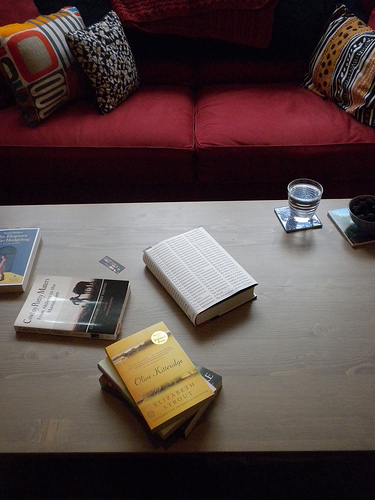<image>
Is there a glass to the left of the book? No. The glass is not to the left of the book. From this viewpoint, they have a different horizontal relationship. Is the water in the coffee? No. The water is not contained within the coffee. These objects have a different spatial relationship. 